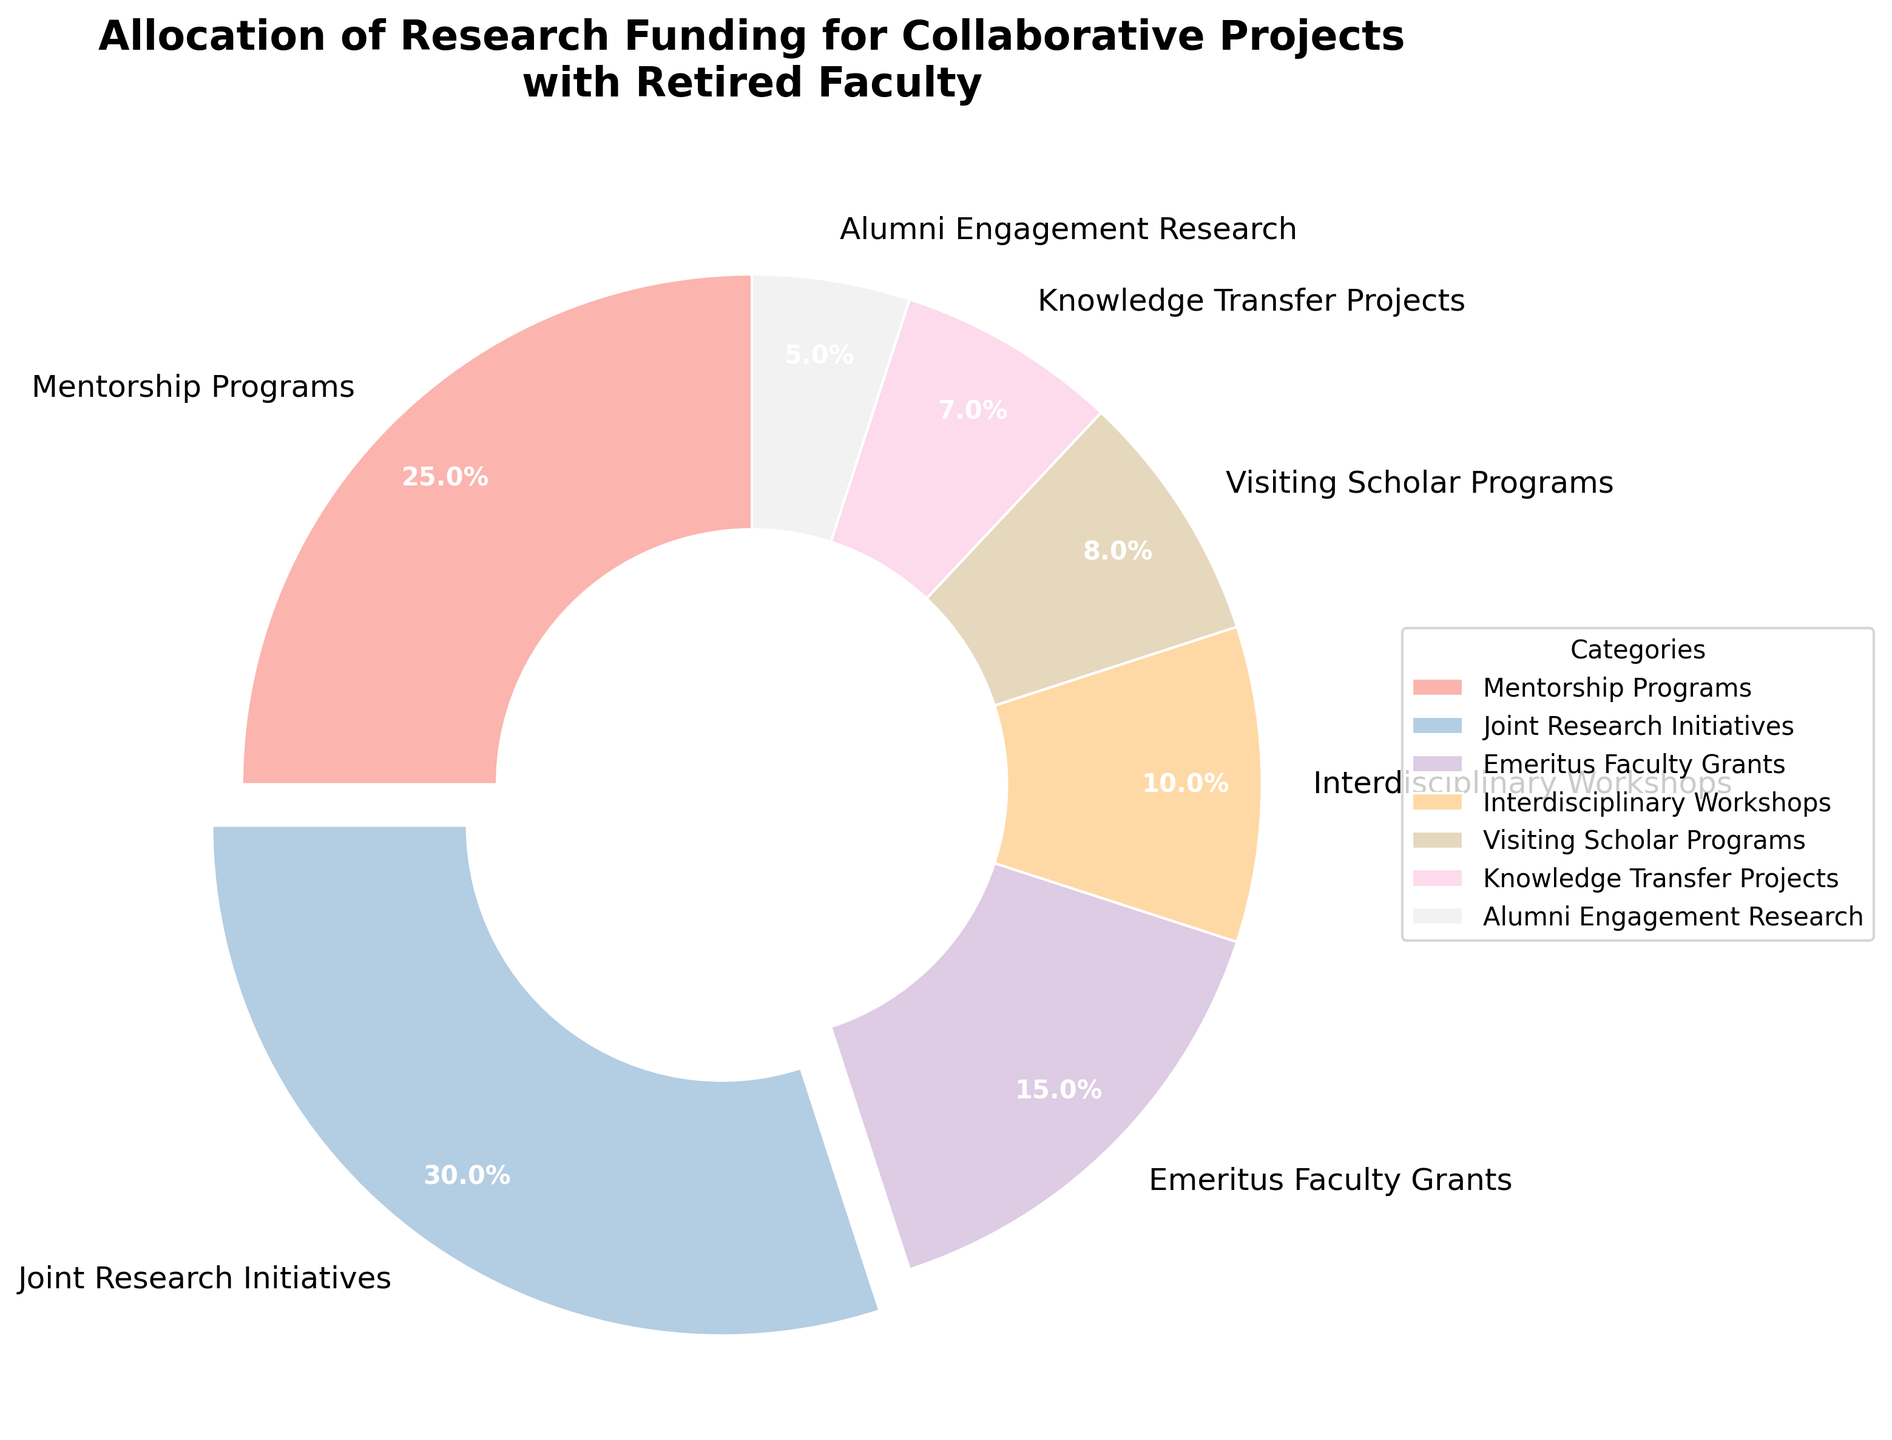What is the category with the highest allocation of research funding? The category with the highest allocation can be identified by looking at the pie slice that has been slightly separated or exploded from the rest. This slice represents Joint Research Initiatives, which has the largest percentage.
Answer: Joint Research Initiatives Which two categories have a combined allocation of more than 50%? To find the combined allocation, we need to add the percentages of different categories and see if the total exceeds 50%. Adding Joint Research Initiatives (30%) and Mentorship Programs (25%) gives 55%, which is more than 50%.
Answer: Joint Research Initiatives and Mentorship Programs What is the average allocation percentage for all the categories? To find the average, we sum up the allocation percentages of all the categories and then divide by the number of categories. The sum is 100% (as it’s a pie chart), and there are 7 categories. Thus, 100% / 7 = 14.29%.
Answer: 14.29% How does the allocation for Knowledge Transfer Projects compare to that of Joint Research Initiatives? Knowledge Transfer Projects have a smaller slice compared to Joint Research Initiatives on the pie chart. Specifically, Knowledge Transfer Projects have 7% and Joint Research Initiatives have 30%, so Knowledge Transfer Projects have a significantly smaller allocation.
Answer: Smaller Which category has the smallest allocation of research funding? By identifying the smallest slice in the pie chart, we can determine that the Alumni Engagement Research category has the smallest percentage at 5%.
Answer: Alumni Engagement Research What is the difference in allocation percentages between Emeritus Faculty Grants and Interdisciplinary Workshops? Emeritus Faculty Grants have 15% allocation while Interdisciplinary Workshops have 10%. The difference is 15% - 10% = 5%.
Answer: 5% Which categories have an allocation percentage less than 10%? By examining the pie chart, we see that Visiting Scholar Programs (8%), Knowledge Transfer Projects (7%), and Alumni Engagement Research (5%) each have less than 10% allocation.
Answer: Visiting Scholar Programs, Knowledge Transfer Projects, Alumni Engagement Research What is the total percentage allocation for categories other than Joint Research Initiatives and Mentorship Programs? Adding the percentages of the remaining categories: Emeritus Faculty Grants (15%), Interdisciplinary Workshops (10%), Visiting Scholar Programs (8%), Knowledge Transfer Projects (7%), and Alumni Engagement Research (5%), gives a total of 45%.
Answer: 45% How does the title of the chart contribute to understanding the context of the data distribution? The title "Allocation of Research Funding for Collaborative Projects with Retired Faculty" clarifies that the chart is about how research funding is distributed across various collaborative projects specifically involving retired faculty, providing necessary context for interpreting the data.
Answer: Provides context for interpreting the data What visual feature indicates the category with the highest allocation percentage? The pie slice representing the category with the highest allocation percentage is slightly separated or exploded from the rest, visually distinguishing it from other slices.
Answer: Slightly separated pie slice 